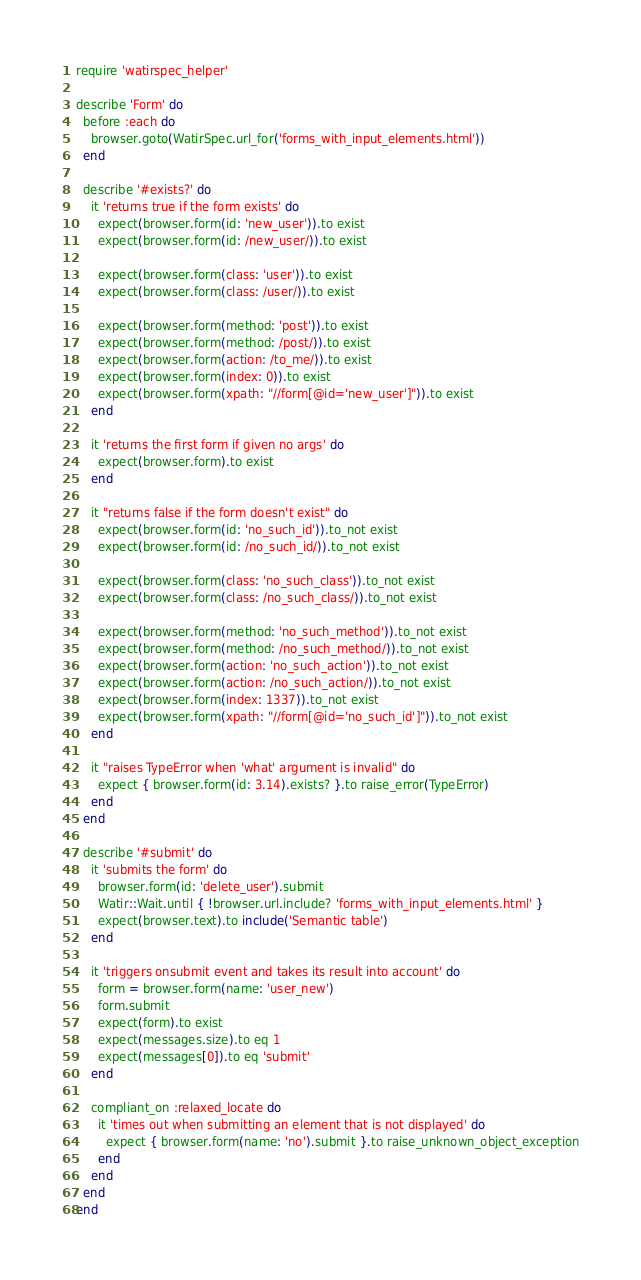Convert code to text. <code><loc_0><loc_0><loc_500><loc_500><_Ruby_>require 'watirspec_helper'

describe 'Form' do
  before :each do
    browser.goto(WatirSpec.url_for('forms_with_input_elements.html'))
  end

  describe '#exists?' do
    it 'returns true if the form exists' do
      expect(browser.form(id: 'new_user')).to exist
      expect(browser.form(id: /new_user/)).to exist

      expect(browser.form(class: 'user')).to exist
      expect(browser.form(class: /user/)).to exist

      expect(browser.form(method: 'post')).to exist
      expect(browser.form(method: /post/)).to exist
      expect(browser.form(action: /to_me/)).to exist
      expect(browser.form(index: 0)).to exist
      expect(browser.form(xpath: "//form[@id='new_user']")).to exist
    end

    it 'returns the first form if given no args' do
      expect(browser.form).to exist
    end

    it "returns false if the form doesn't exist" do
      expect(browser.form(id: 'no_such_id')).to_not exist
      expect(browser.form(id: /no_such_id/)).to_not exist

      expect(browser.form(class: 'no_such_class')).to_not exist
      expect(browser.form(class: /no_such_class/)).to_not exist

      expect(browser.form(method: 'no_such_method')).to_not exist
      expect(browser.form(method: /no_such_method/)).to_not exist
      expect(browser.form(action: 'no_such_action')).to_not exist
      expect(browser.form(action: /no_such_action/)).to_not exist
      expect(browser.form(index: 1337)).to_not exist
      expect(browser.form(xpath: "//form[@id='no_such_id']")).to_not exist
    end

    it "raises TypeError when 'what' argument is invalid" do
      expect { browser.form(id: 3.14).exists? }.to raise_error(TypeError)
    end
  end

  describe '#submit' do
    it 'submits the form' do
      browser.form(id: 'delete_user').submit
      Watir::Wait.until { !browser.url.include? 'forms_with_input_elements.html' }
      expect(browser.text).to include('Semantic table')
    end

    it 'triggers onsubmit event and takes its result into account' do
      form = browser.form(name: 'user_new')
      form.submit
      expect(form).to exist
      expect(messages.size).to eq 1
      expect(messages[0]).to eq 'submit'
    end

    compliant_on :relaxed_locate do
      it 'times out when submitting an element that is not displayed' do
        expect { browser.form(name: 'no').submit }.to raise_unknown_object_exception
      end
    end
  end
end
</code> 